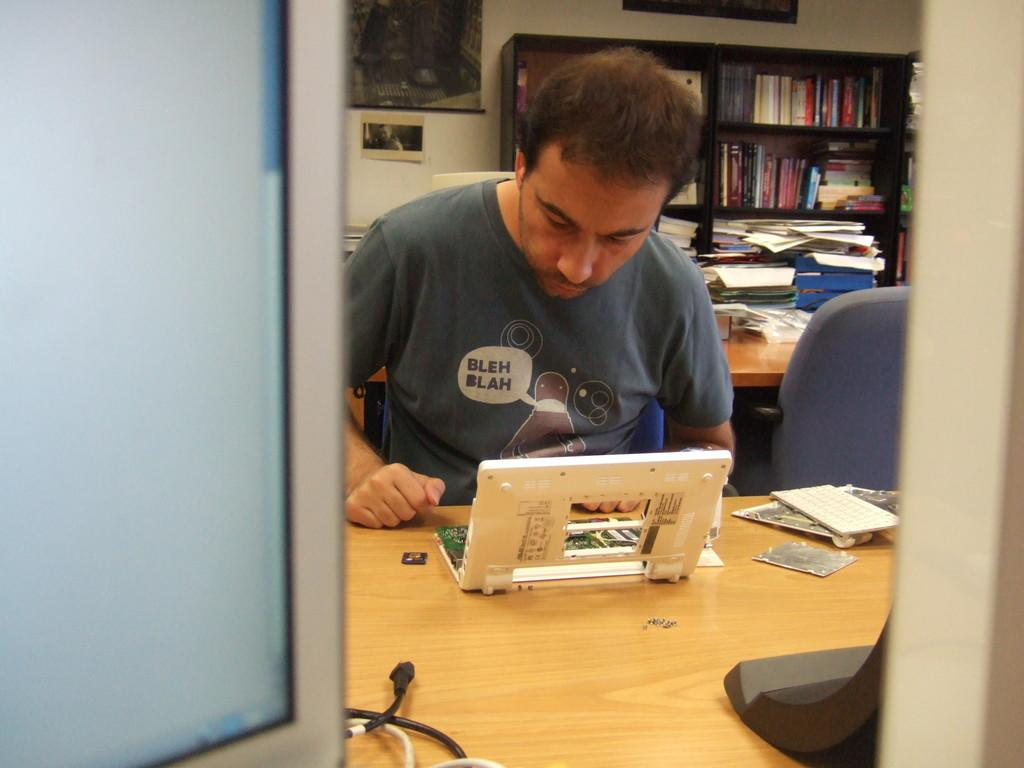What is the man in the image doing? The man is sitting on a chair in the image. What can be seen on the table in the image? There are electrical materials on a table in the image. What is located at the back side of the image? There is a book rack visible at the back side of the image. How many crows are sitting on the book rack in the image? There are no crows present in the image; it only features a man sitting on a chair, electrical materials on a table, and a book rack. 